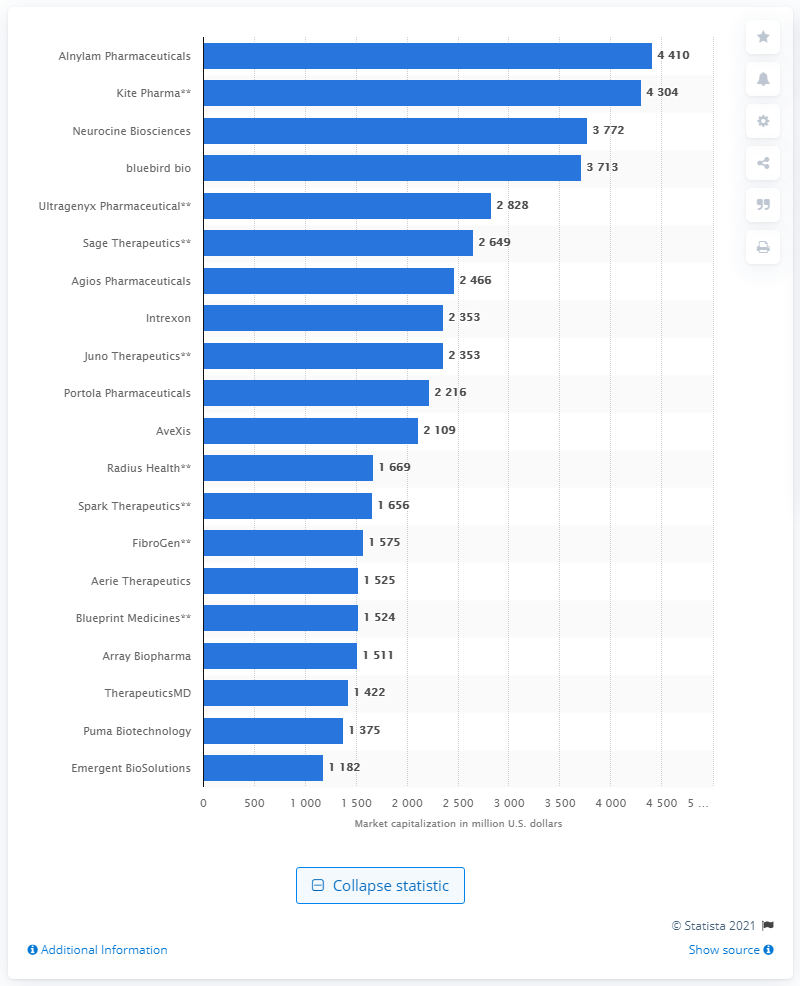Indicate a few pertinent items in this graphic. As of March 2017, Puma Biotechnology's market capitalization was 1,375. 